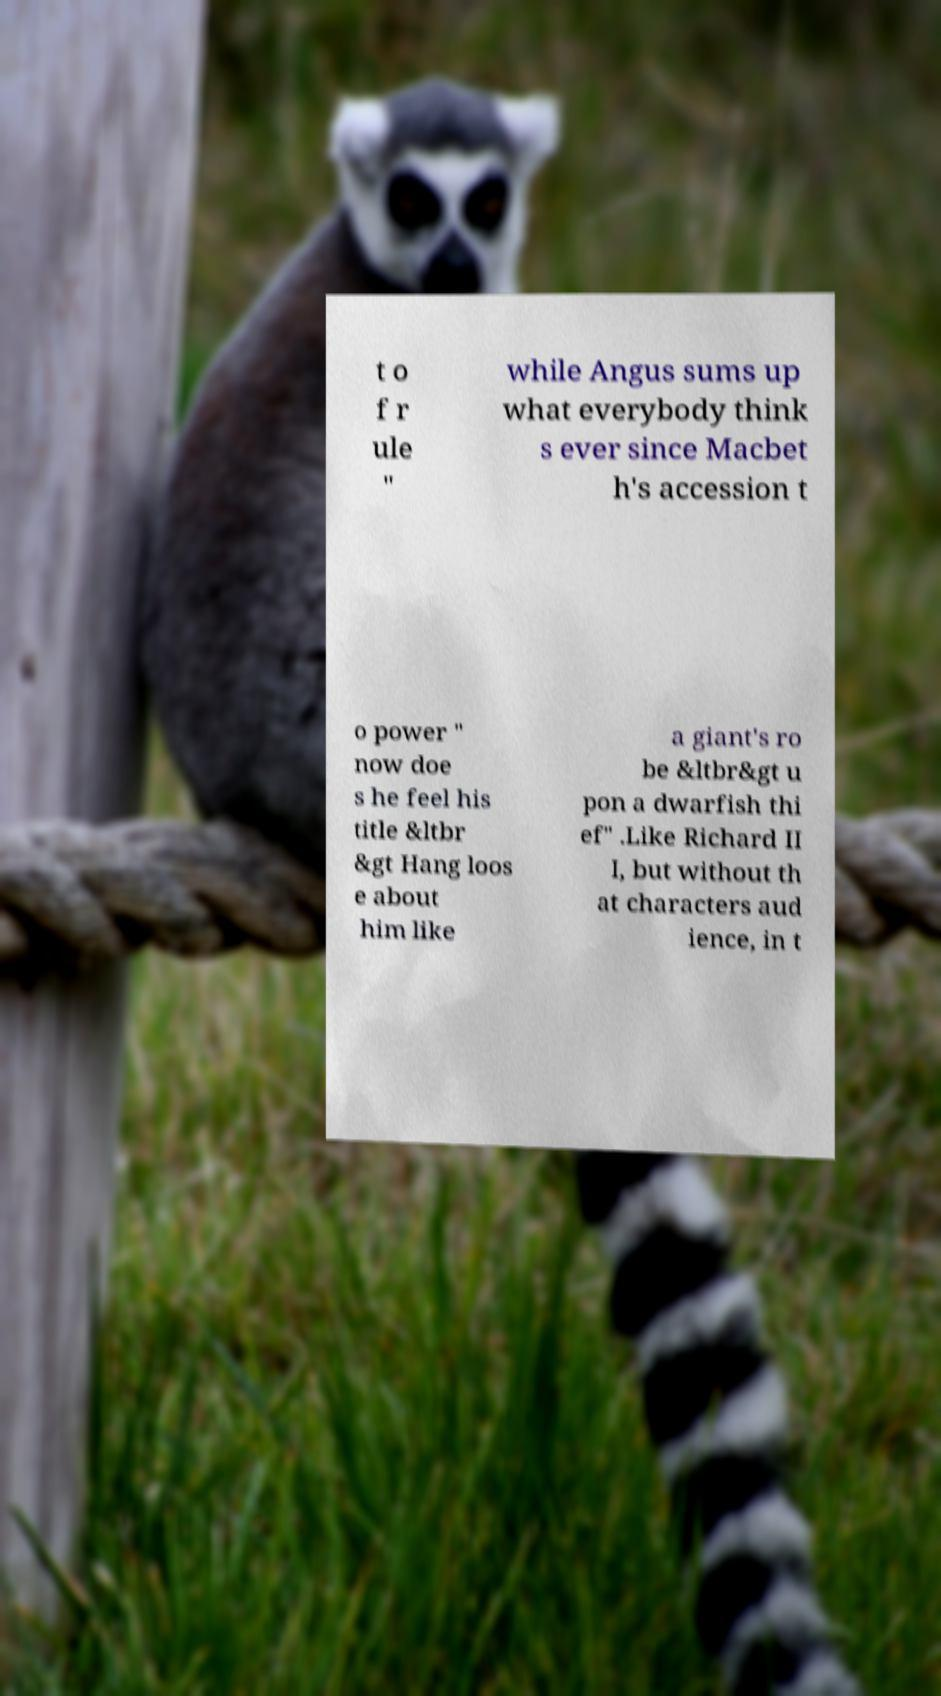There's text embedded in this image that I need extracted. Can you transcribe it verbatim? t o f r ule " while Angus sums up what everybody think s ever since Macbet h's accession t o power " now doe s he feel his title &ltbr &gt Hang loos e about him like a giant's ro be &ltbr&gt u pon a dwarfish thi ef" .Like Richard II I, but without th at characters aud ience, in t 